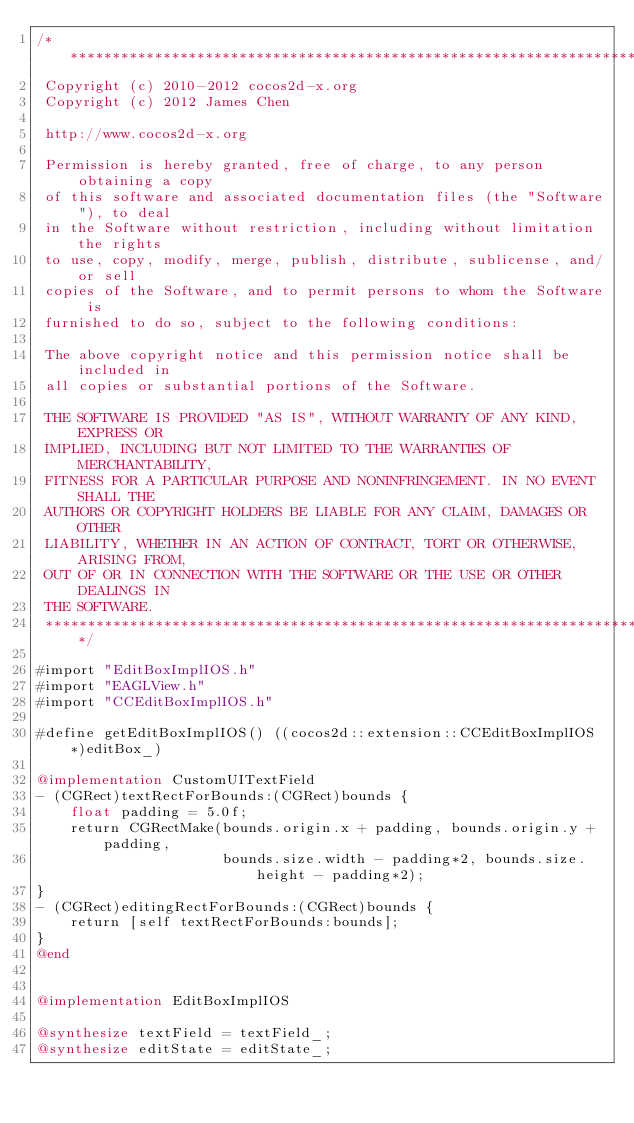Convert code to text. <code><loc_0><loc_0><loc_500><loc_500><_ObjectiveC_>/****************************************************************************
 Copyright (c) 2010-2012 cocos2d-x.org
 Copyright (c) 2012 James Chen
 
 http://www.cocos2d-x.org
 
 Permission is hereby granted, free of charge, to any person obtaining a copy
 of this software and associated documentation files (the "Software"), to deal
 in the Software without restriction, including without limitation the rights
 to use, copy, modify, merge, publish, distribute, sublicense, and/or sell
 copies of the Software, and to permit persons to whom the Software is
 furnished to do so, subject to the following conditions:
 
 The above copyright notice and this permission notice shall be included in
 all copies or substantial portions of the Software.
 
 THE SOFTWARE IS PROVIDED "AS IS", WITHOUT WARRANTY OF ANY KIND, EXPRESS OR
 IMPLIED, INCLUDING BUT NOT LIMITED TO THE WARRANTIES OF MERCHANTABILITY,
 FITNESS FOR A PARTICULAR PURPOSE AND NONINFRINGEMENT. IN NO EVENT SHALL THE
 AUTHORS OR COPYRIGHT HOLDERS BE LIABLE FOR ANY CLAIM, DAMAGES OR OTHER
 LIABILITY, WHETHER IN AN ACTION OF CONTRACT, TORT OR OTHERWISE, ARISING FROM,
 OUT OF OR IN CONNECTION WITH THE SOFTWARE OR THE USE OR OTHER DEALINGS IN
 THE SOFTWARE.
 ****************************************************************************/

#import "EditBoxImplIOS.h"
#import "EAGLView.h"
#import "CCEditBoxImplIOS.h"

#define getEditBoxImplIOS() ((cocos2d::extension::CCEditBoxImplIOS*)editBox_)

@implementation CustomUITextField
- (CGRect)textRectForBounds:(CGRect)bounds {
    float padding = 5.0f;
    return CGRectMake(bounds.origin.x + padding, bounds.origin.y + padding,
                      bounds.size.width - padding*2, bounds.size.height - padding*2);
}
- (CGRect)editingRectForBounds:(CGRect)bounds {
    return [self textRectForBounds:bounds];
}
@end


@implementation EditBoxImplIOS

@synthesize textField = textField_;
@synthesize editState = editState_;</code> 